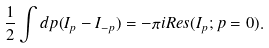<formula> <loc_0><loc_0><loc_500><loc_500>\frac { 1 } { 2 } \int d p ( I _ { p } - I _ { - p } ) = - \pi i { R e s } ( I _ { p } ; p = 0 ) .</formula> 